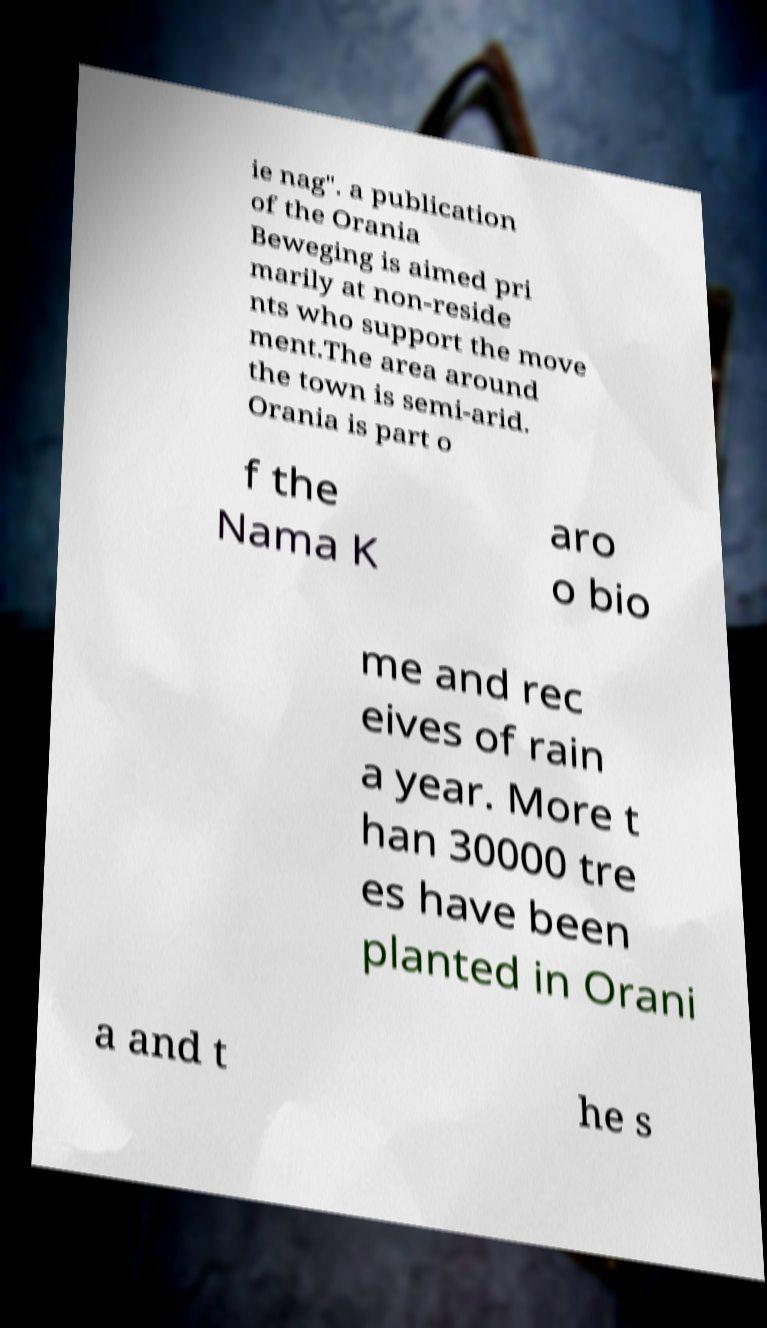For documentation purposes, I need the text within this image transcribed. Could you provide that? ie nag". a publication of the Orania Beweging is aimed pri marily at non-reside nts who support the move ment.The area around the town is semi-arid. Orania is part o f the Nama K aro o bio me and rec eives of rain a year. More t han 30000 tre es have been planted in Orani a and t he s 